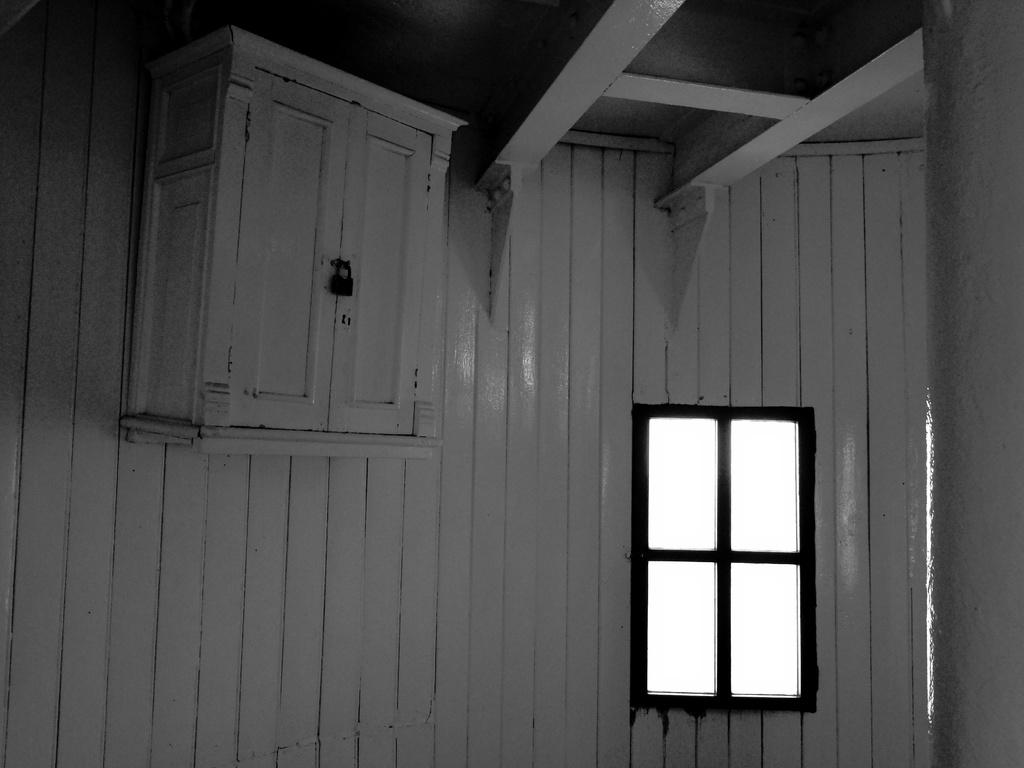What can be seen in the image that allows light to enter the room? There is a window in the image. What material is used for the walls in the image? The walls in the image are made of wood. What type of furniture is present in the image? There are shelves in the image. What type of cracker is being used to build the structure in the image? There is no structure or cracker present in the image. What type of beef is being served on the shelves in the image? There is no beef present in the image; it only features shelves. 